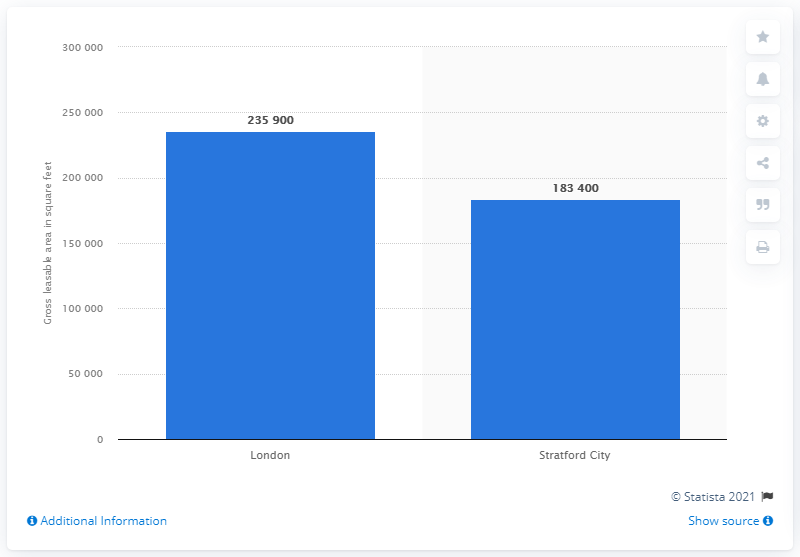Give some essential details in this illustration. The Gross Leasable Area of Stratford City shopping center was 183,400 square feet. 